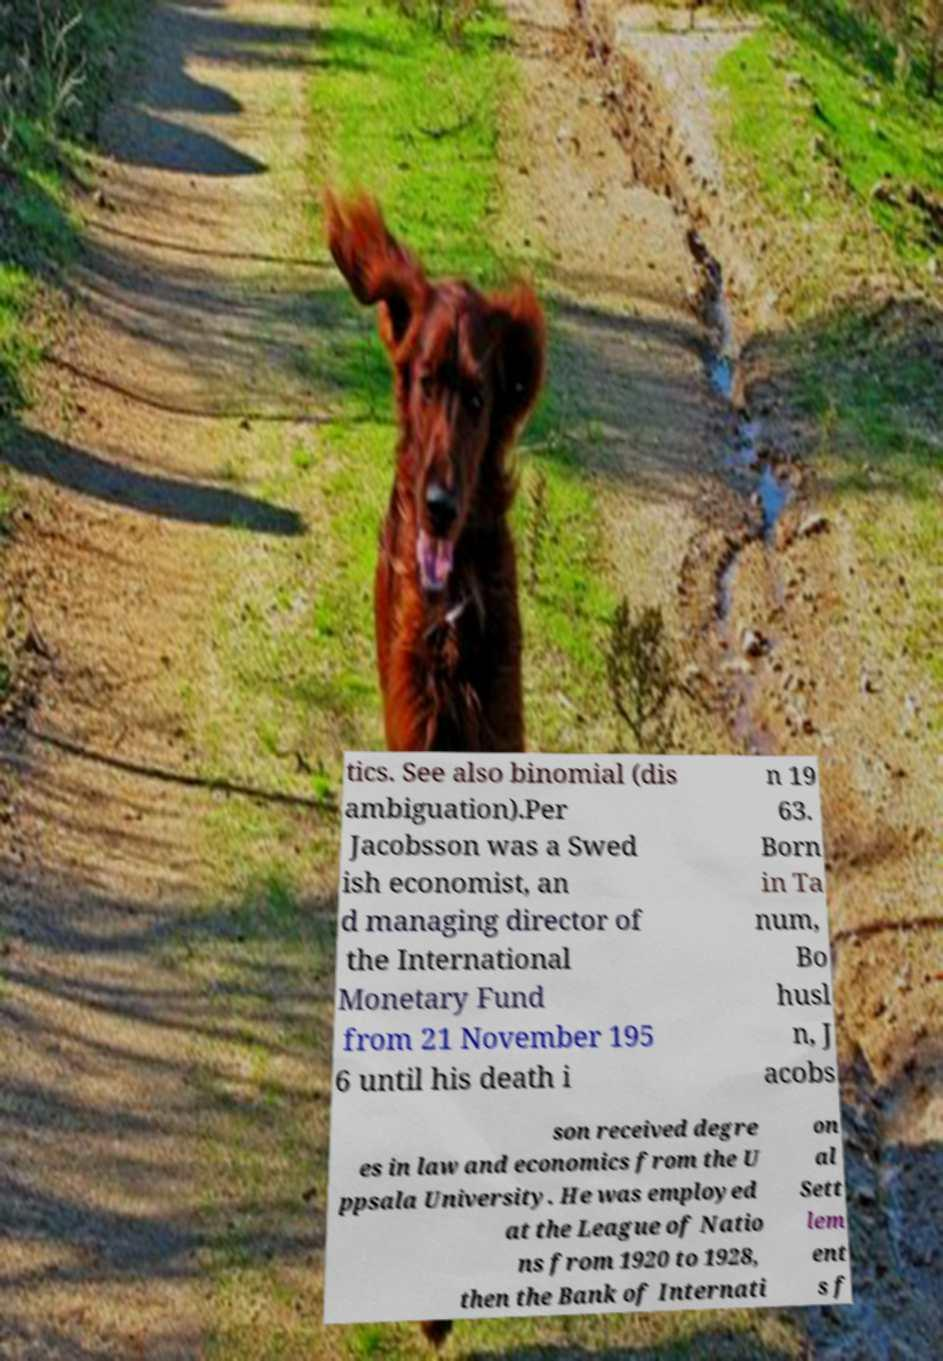Could you assist in decoding the text presented in this image and type it out clearly? tics. See also binomial (dis ambiguation).Per Jacobsson was a Swed ish economist, an d managing director of the International Monetary Fund from 21 November 195 6 until his death i n 19 63. Born in Ta num, Bo husl n, J acobs son received degre es in law and economics from the U ppsala University. He was employed at the League of Natio ns from 1920 to 1928, then the Bank of Internati on al Sett lem ent s f 